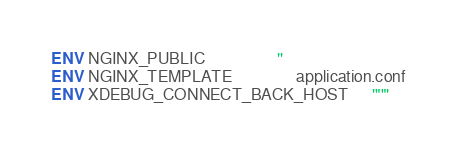Convert code to text. <code><loc_0><loc_0><loc_500><loc_500><_Dockerfile_>ENV NGINX_PUBLIC                  ''
ENV NGINX_TEMPLATE                application.conf
ENV XDEBUG_CONNECT_BACK_HOST      '""'</code> 